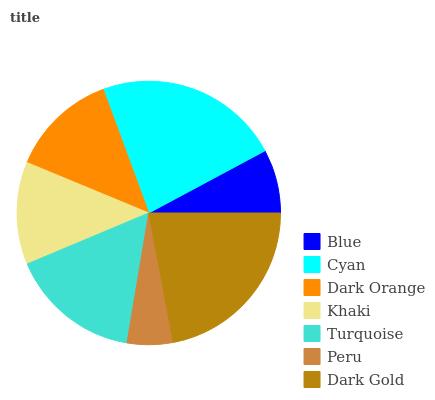Is Peru the minimum?
Answer yes or no. Yes. Is Cyan the maximum?
Answer yes or no. Yes. Is Dark Orange the minimum?
Answer yes or no. No. Is Dark Orange the maximum?
Answer yes or no. No. Is Cyan greater than Dark Orange?
Answer yes or no. Yes. Is Dark Orange less than Cyan?
Answer yes or no. Yes. Is Dark Orange greater than Cyan?
Answer yes or no. No. Is Cyan less than Dark Orange?
Answer yes or no. No. Is Dark Orange the high median?
Answer yes or no. Yes. Is Dark Orange the low median?
Answer yes or no. Yes. Is Khaki the high median?
Answer yes or no. No. Is Blue the low median?
Answer yes or no. No. 